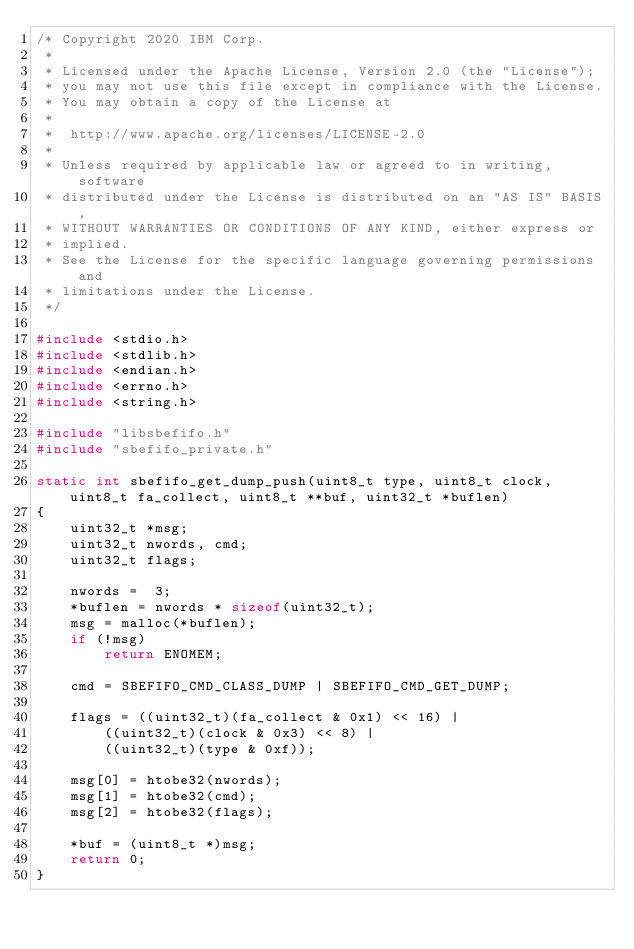<code> <loc_0><loc_0><loc_500><loc_500><_C_>/* Copyright 2020 IBM Corp.
 *
 * Licensed under the Apache License, Version 2.0 (the "License");
 * you may not use this file except in compliance with the License.
 * You may obtain a copy of the License at
 *
 * 	http://www.apache.org/licenses/LICENSE-2.0
 *
 * Unless required by applicable law or agreed to in writing, software
 * distributed under the License is distributed on an "AS IS" BASIS,
 * WITHOUT WARRANTIES OR CONDITIONS OF ANY KIND, either express or
 * implied.
 * See the License for the specific language governing permissions and
 * limitations under the License.
 */

#include <stdio.h>
#include <stdlib.h>
#include <endian.h>
#include <errno.h>
#include <string.h>

#include "libsbefifo.h"
#include "sbefifo_private.h"

static int sbefifo_get_dump_push(uint8_t type, uint8_t clock, uint8_t fa_collect, uint8_t **buf, uint32_t *buflen)
{
	uint32_t *msg;
	uint32_t nwords, cmd;
	uint32_t flags;

	nwords =  3;
	*buflen = nwords * sizeof(uint32_t);
	msg = malloc(*buflen);
	if (!msg)
		return ENOMEM;

	cmd = SBEFIFO_CMD_CLASS_DUMP | SBEFIFO_CMD_GET_DUMP;

	flags = ((uint32_t)(fa_collect & 0x1) << 16) |
		((uint32_t)(clock & 0x3) << 8) |
		((uint32_t)(type & 0xf));

	msg[0] = htobe32(nwords);
	msg[1] = htobe32(cmd);
	msg[2] = htobe32(flags);

	*buf = (uint8_t *)msg;
	return 0;
}
</code> 